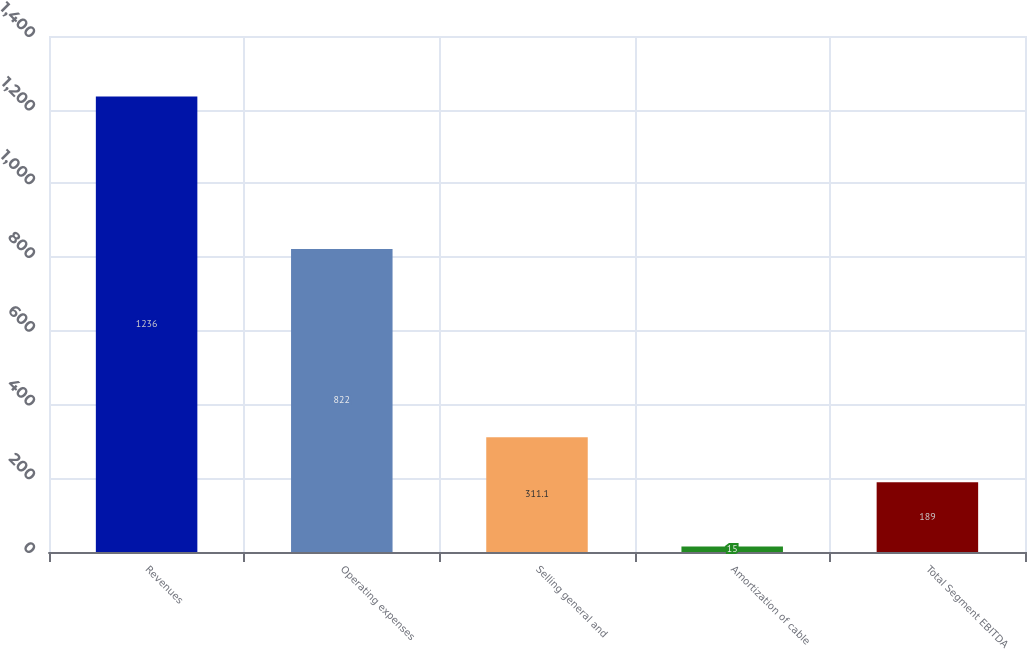<chart> <loc_0><loc_0><loc_500><loc_500><bar_chart><fcel>Revenues<fcel>Operating expenses<fcel>Selling general and<fcel>Amortization of cable<fcel>Total Segment EBITDA<nl><fcel>1236<fcel>822<fcel>311.1<fcel>15<fcel>189<nl></chart> 